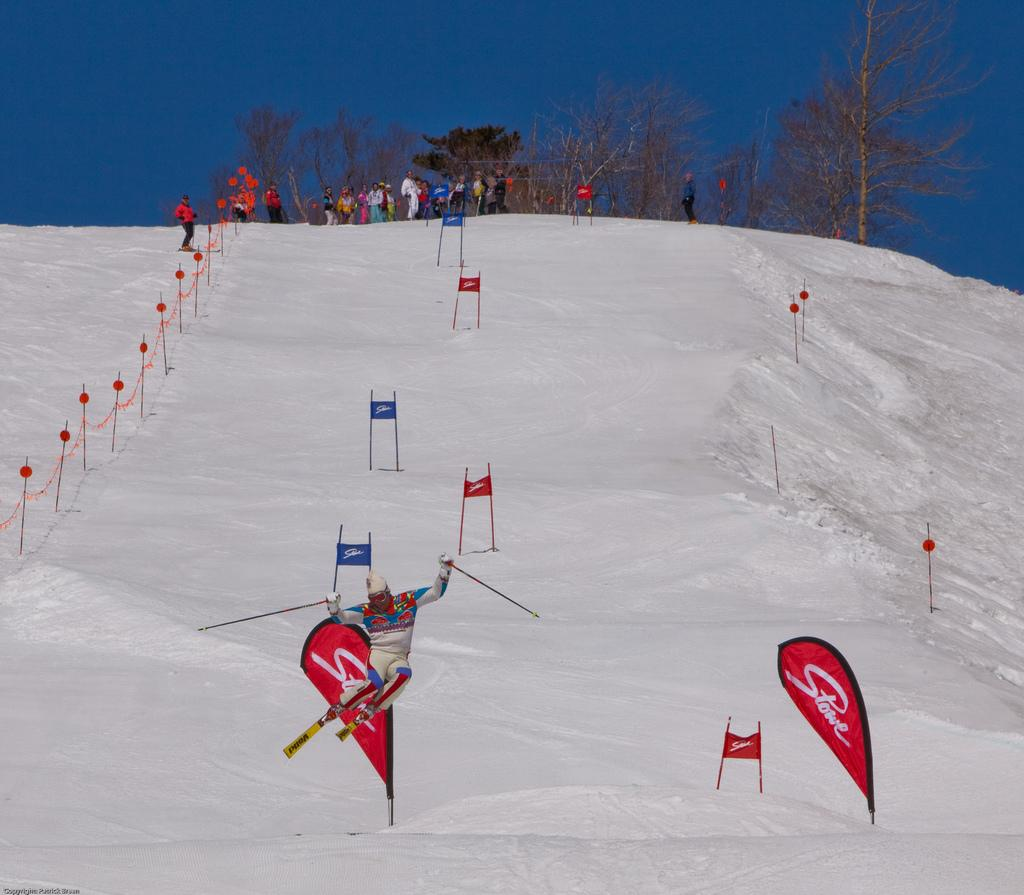<image>
Offer a succinct explanation of the picture presented. Skiers skiing, and some spectating, at a Stowe ski mountain location 